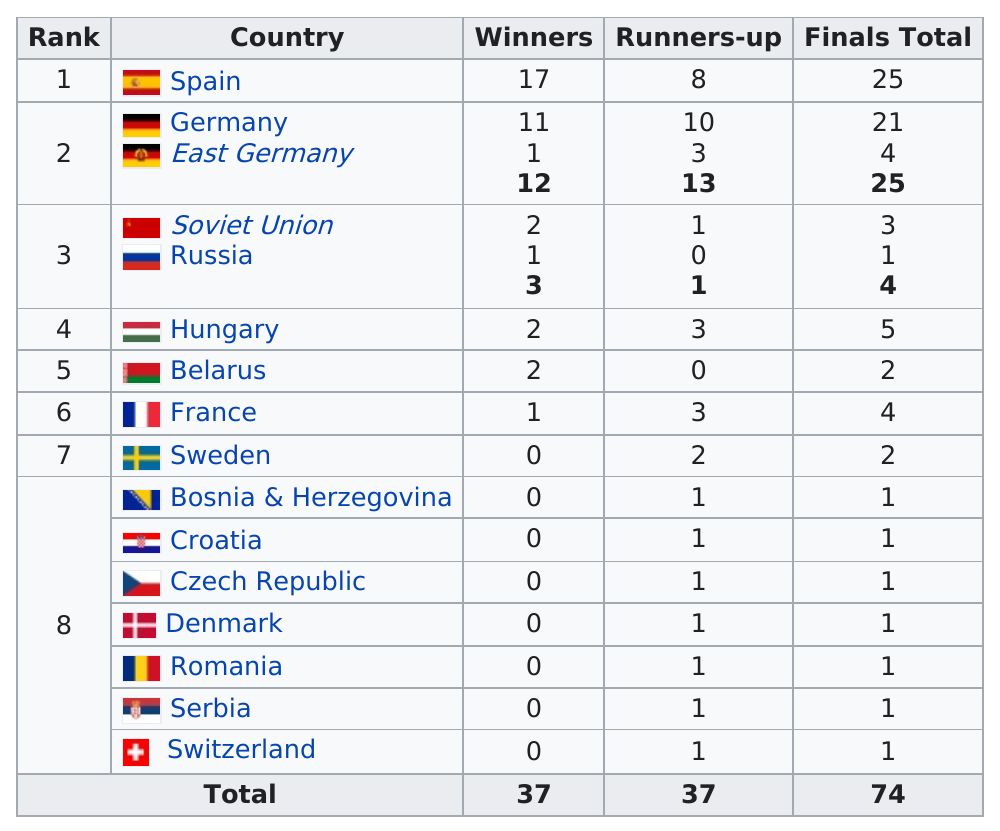Outline some significant characteristics in this image. The number of top 8 ranked countries is 16. The total number of winners was 37. Hungary was the only team to score a total of 5 goals in the match. The question asks whether France or Croatia had a larger final score in a competition or event. The answer provided is that France had a larger final score. The total number of runners-up from Sweden was 2. 